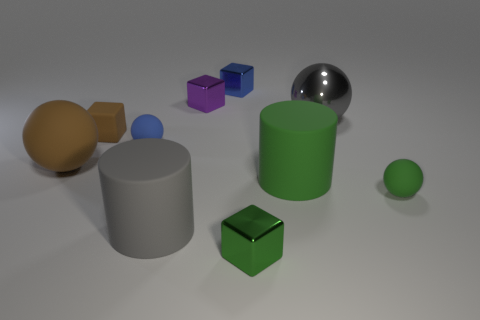How many large objects are to the left of the gray object that is on the right side of the small green thing left of the big gray shiny ball?
Your answer should be very brief. 3. How many small blue matte things are there?
Ensure brevity in your answer.  1. Is the number of blue balls that are on the left side of the metal ball less than the number of gray cylinders to the left of the big brown thing?
Offer a terse response. No. Is the number of tiny blue blocks in front of the green sphere less than the number of small objects?
Provide a succinct answer. Yes. There is a big ball that is in front of the small blue ball right of the brown thing that is right of the brown sphere; what is it made of?
Offer a very short reply. Rubber. How many things are either large balls to the left of the tiny rubber cube or matte things that are in front of the big green object?
Keep it short and to the point. 3. There is a green object that is the same shape as the tiny blue matte thing; what material is it?
Provide a short and direct response. Rubber. How many matte things are blue spheres or small balls?
Your response must be concise. 2. There is a gray thing that is made of the same material as the small green sphere; what shape is it?
Offer a very short reply. Cylinder. What number of other big objects have the same shape as the large gray shiny object?
Provide a short and direct response. 1. 